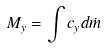<formula> <loc_0><loc_0><loc_500><loc_500>M _ { y } = \int c _ { y } d \dot { m }</formula> 